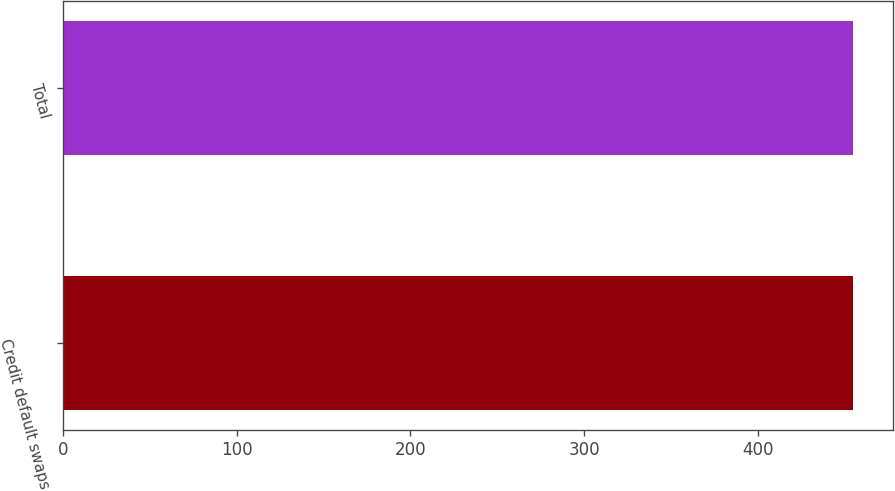Convert chart. <chart><loc_0><loc_0><loc_500><loc_500><bar_chart><fcel>Credit default swaps<fcel>Total<nl><fcel>455<fcel>455.1<nl></chart> 